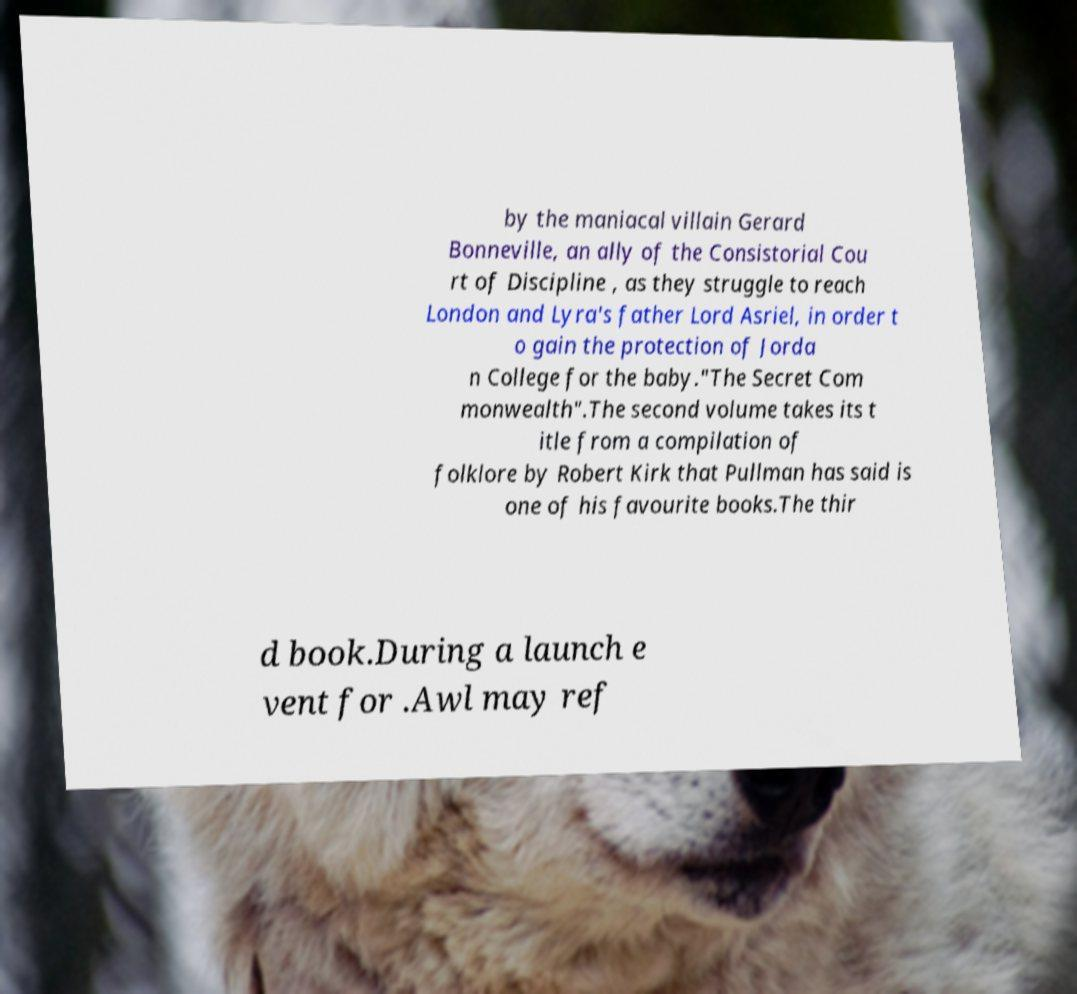Could you assist in decoding the text presented in this image and type it out clearly? by the maniacal villain Gerard Bonneville, an ally of the Consistorial Cou rt of Discipline , as they struggle to reach London and Lyra's father Lord Asriel, in order t o gain the protection of Jorda n College for the baby."The Secret Com monwealth".The second volume takes its t itle from a compilation of folklore by Robert Kirk that Pullman has said is one of his favourite books.The thir d book.During a launch e vent for .Awl may ref 